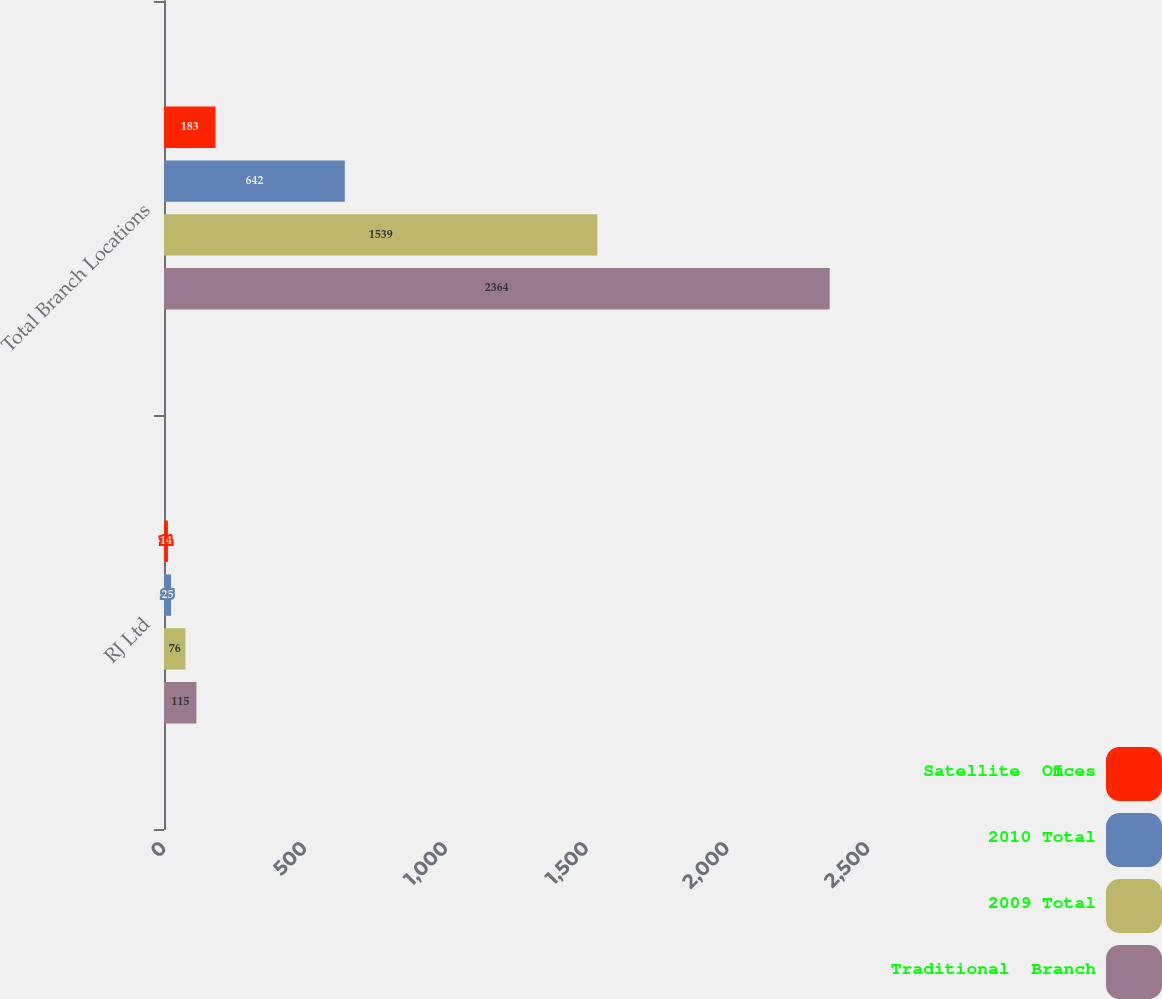Convert chart. <chart><loc_0><loc_0><loc_500><loc_500><stacked_bar_chart><ecel><fcel>RJ Ltd<fcel>Total Branch Locations<nl><fcel>Satellite  Offices<fcel>14<fcel>183<nl><fcel>2010 Total<fcel>25<fcel>642<nl><fcel>2009 Total<fcel>76<fcel>1539<nl><fcel>Traditional  Branch<fcel>115<fcel>2364<nl></chart> 